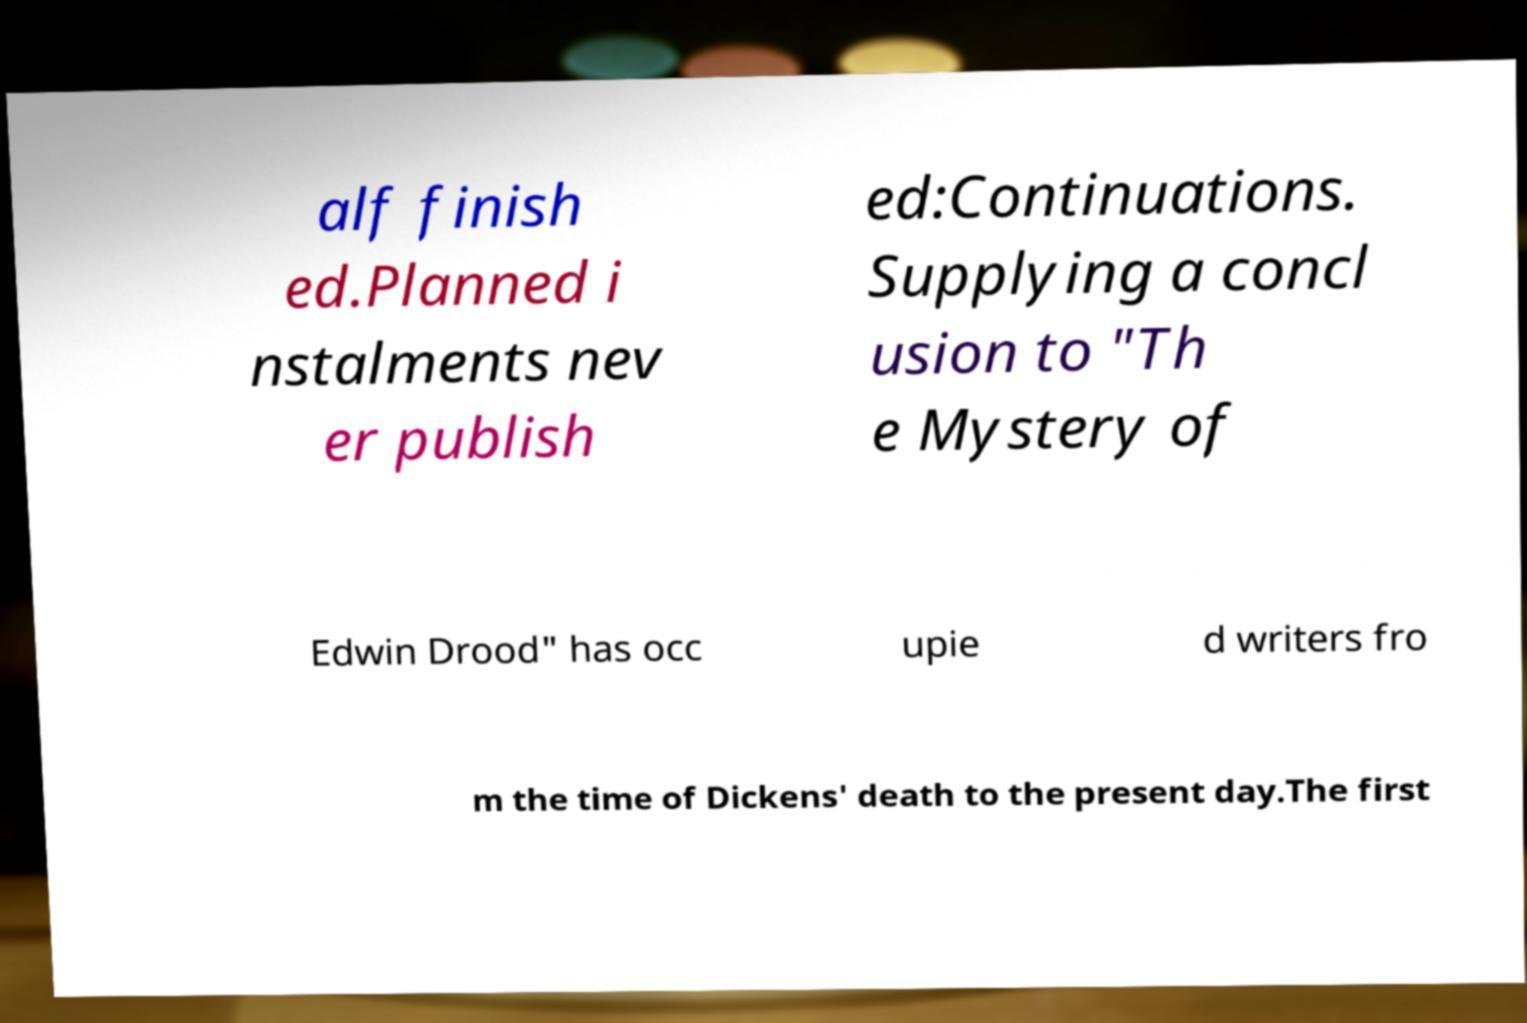Can you accurately transcribe the text from the provided image for me? alf finish ed.Planned i nstalments nev er publish ed:Continuations. Supplying a concl usion to "Th e Mystery of Edwin Drood" has occ upie d writers fro m the time of Dickens' death to the present day.The first 